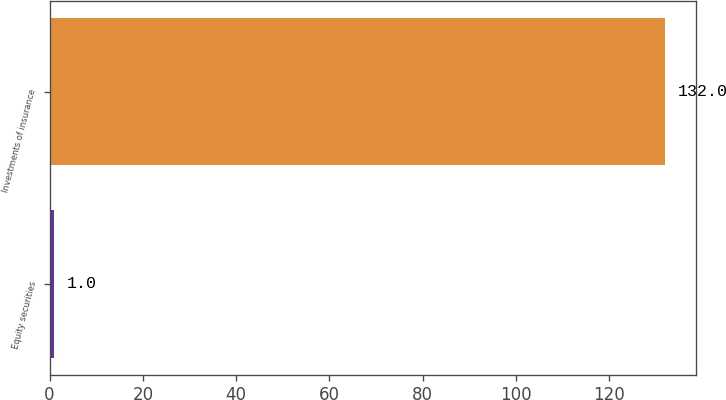Convert chart. <chart><loc_0><loc_0><loc_500><loc_500><bar_chart><fcel>Equity securities<fcel>Investments of insurance<nl><fcel>1<fcel>132<nl></chart> 